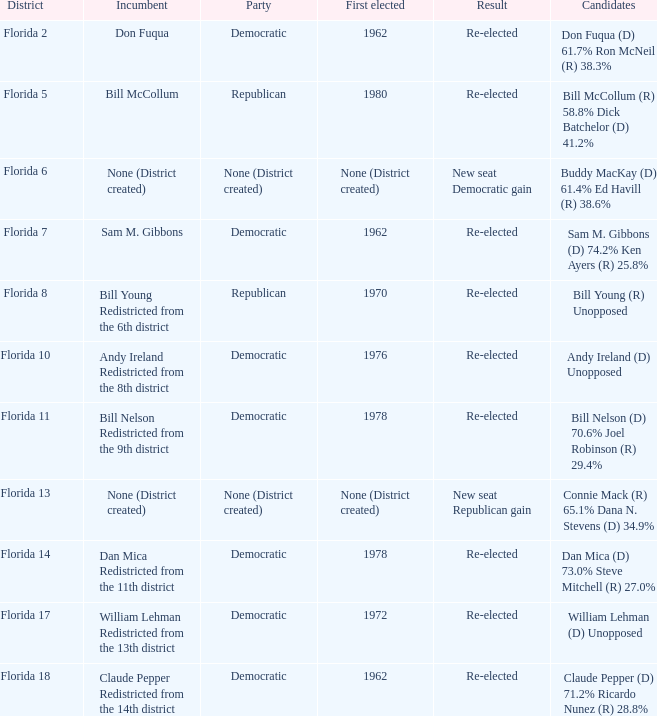Parse the table in full. {'header': ['District', 'Incumbent', 'Party', 'First elected', 'Result', 'Candidates'], 'rows': [['Florida 2', 'Don Fuqua', 'Democratic', '1962', 'Re-elected', 'Don Fuqua (D) 61.7% Ron McNeil (R) 38.3%'], ['Florida 5', 'Bill McCollum', 'Republican', '1980', 'Re-elected', 'Bill McCollum (R) 58.8% Dick Batchelor (D) 41.2%'], ['Florida 6', 'None (District created)', 'None (District created)', 'None (District created)', 'New seat Democratic gain', 'Buddy MacKay (D) 61.4% Ed Havill (R) 38.6%'], ['Florida 7', 'Sam M. Gibbons', 'Democratic', '1962', 'Re-elected', 'Sam M. Gibbons (D) 74.2% Ken Ayers (R) 25.8%'], ['Florida 8', 'Bill Young Redistricted from the 6th district', 'Republican', '1970', 'Re-elected', 'Bill Young (R) Unopposed'], ['Florida 10', 'Andy Ireland Redistricted from the 8th district', 'Democratic', '1976', 'Re-elected', 'Andy Ireland (D) Unopposed'], ['Florida 11', 'Bill Nelson Redistricted from the 9th district', 'Democratic', '1978', 'Re-elected', 'Bill Nelson (D) 70.6% Joel Robinson (R) 29.4%'], ['Florida 13', 'None (District created)', 'None (District created)', 'None (District created)', 'New seat Republican gain', 'Connie Mack (R) 65.1% Dana N. Stevens (D) 34.9%'], ['Florida 14', 'Dan Mica Redistricted from the 11th district', 'Democratic', '1978', 'Re-elected', 'Dan Mica (D) 73.0% Steve Mitchell (R) 27.0%'], ['Florida 17', 'William Lehman Redistricted from the 13th district', 'Democratic', '1972', 'Re-elected', 'William Lehman (D) Unopposed'], ['Florida 18', 'Claude Pepper Redistricted from the 14th district', 'Democratic', '1962', 'Re-elected', 'Claude Pepper (D) 71.2% Ricardo Nunez (R) 28.8%']]} In which district is the result a new seat gain for the democratic party? Florida 6. 